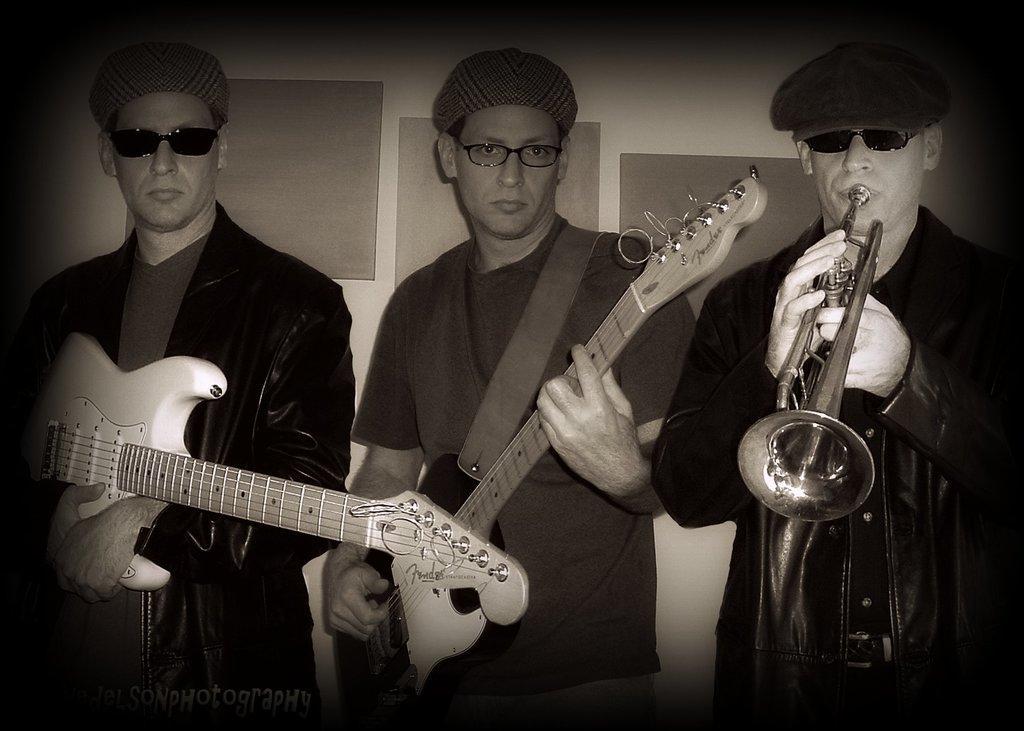In one or two sentences, can you explain what this image depicts? In this image there are three man the two man here are hold the guitar and playing ,the man stand here is playing the musical instrument,at the back ground i can see a wall. 